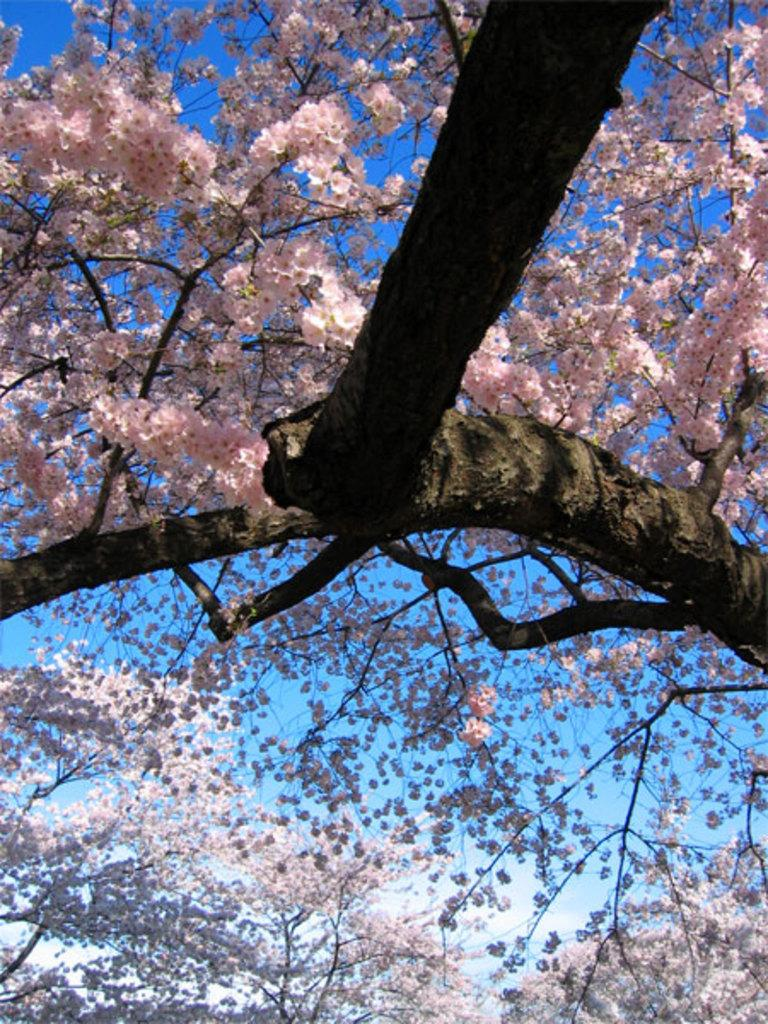What type of plant can be seen in the image? There is a tree with flowers in the image. What part of the natural environment is visible in the image? The sky is visible in the image. What type of apparel is the kitten wearing in the image? There is no kitten present in the image, and therefore no apparel can be observed. 